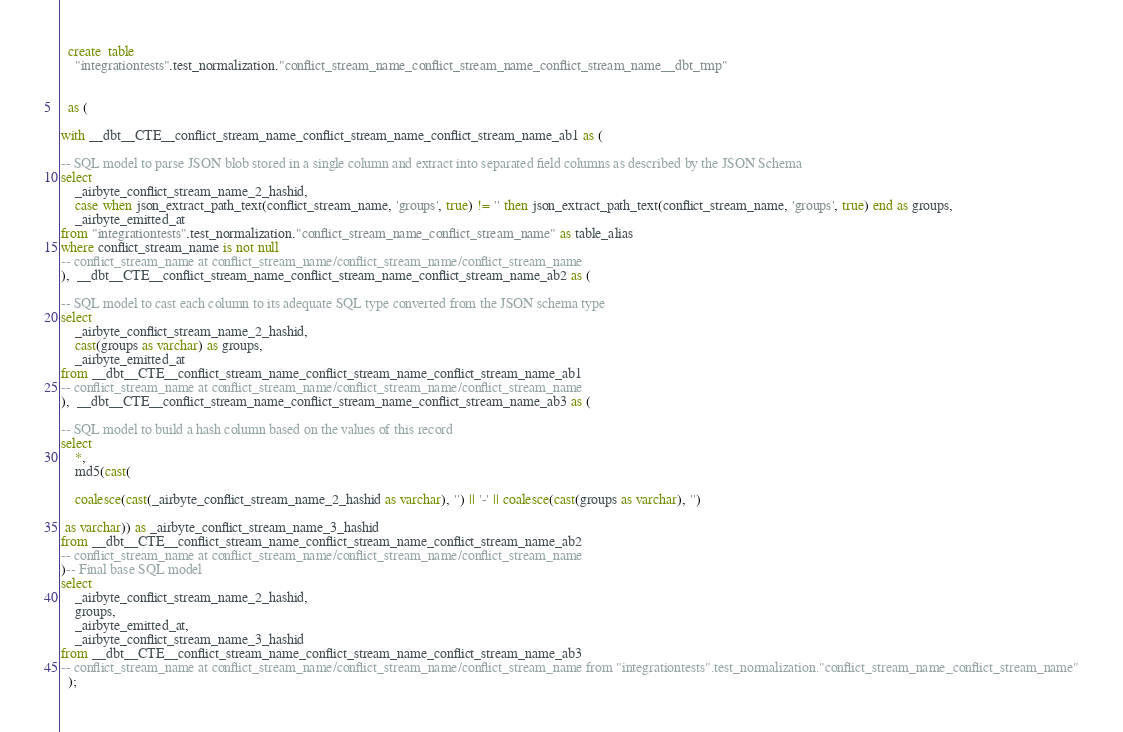<code> <loc_0><loc_0><loc_500><loc_500><_SQL_>

  create  table
    "integrationtests".test_normalization."conflict_stream_name_conflict_stream_name_conflict_stream_name__dbt_tmp"
    
    
  as (
    
with __dbt__CTE__conflict_stream_name_conflict_stream_name_conflict_stream_name_ab1 as (

-- SQL model to parse JSON blob stored in a single column and extract into separated field columns as described by the JSON Schema
select
    _airbyte_conflict_stream_name_2_hashid,
    case when json_extract_path_text(conflict_stream_name, 'groups', true) != '' then json_extract_path_text(conflict_stream_name, 'groups', true) end as groups,
    _airbyte_emitted_at
from "integrationtests".test_normalization."conflict_stream_name_conflict_stream_name" as table_alias
where conflict_stream_name is not null
-- conflict_stream_name at conflict_stream_name/conflict_stream_name/conflict_stream_name
),  __dbt__CTE__conflict_stream_name_conflict_stream_name_conflict_stream_name_ab2 as (

-- SQL model to cast each column to its adequate SQL type converted from the JSON schema type
select
    _airbyte_conflict_stream_name_2_hashid,
    cast(groups as varchar) as groups,
    _airbyte_emitted_at
from __dbt__CTE__conflict_stream_name_conflict_stream_name_conflict_stream_name_ab1
-- conflict_stream_name at conflict_stream_name/conflict_stream_name/conflict_stream_name
),  __dbt__CTE__conflict_stream_name_conflict_stream_name_conflict_stream_name_ab3 as (

-- SQL model to build a hash column based on the values of this record
select
    *,
    md5(cast(
    
    coalesce(cast(_airbyte_conflict_stream_name_2_hashid as varchar), '') || '-' || coalesce(cast(groups as varchar), '')

 as varchar)) as _airbyte_conflict_stream_name_3_hashid
from __dbt__CTE__conflict_stream_name_conflict_stream_name_conflict_stream_name_ab2
-- conflict_stream_name at conflict_stream_name/conflict_stream_name/conflict_stream_name
)-- Final base SQL model
select
    _airbyte_conflict_stream_name_2_hashid,
    groups,
    _airbyte_emitted_at,
    _airbyte_conflict_stream_name_3_hashid
from __dbt__CTE__conflict_stream_name_conflict_stream_name_conflict_stream_name_ab3
-- conflict_stream_name at conflict_stream_name/conflict_stream_name/conflict_stream_name from "integrationtests".test_normalization."conflict_stream_name_conflict_stream_name"
  );</code> 